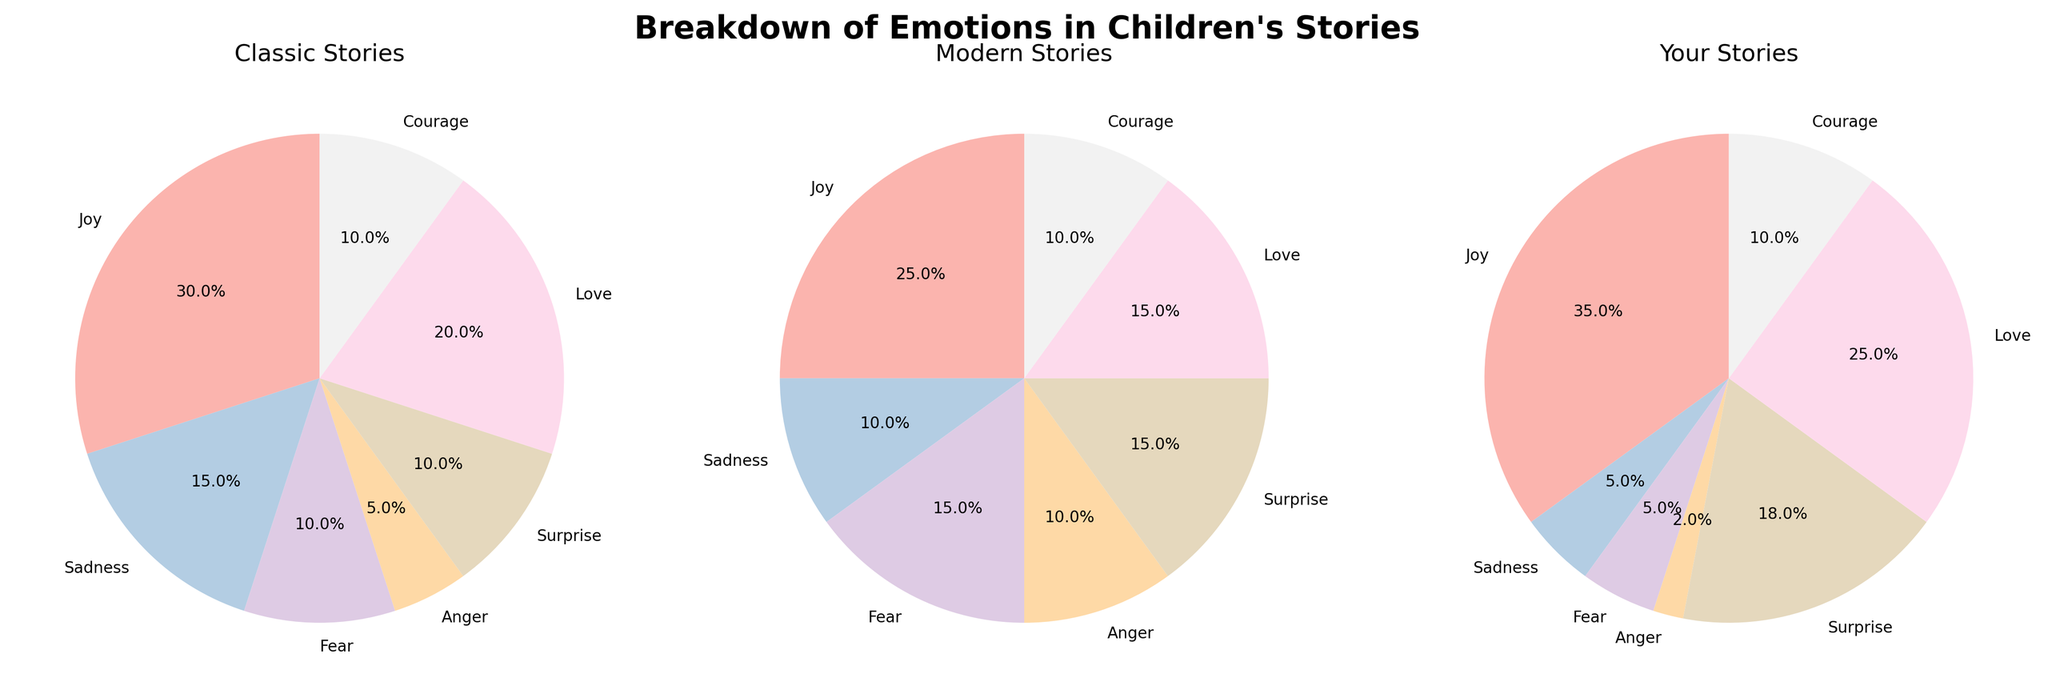Which story type has the highest percentage of 'Joy' depicted? To determine which story type has the highest percentage of 'Joy,' look at each pie chart's section labeled 'Joy' and compare their percentages. 'Your Stories' have 35%, which is higher than the other two categories.
Answer: Your Stories What is the combined percentage of 'Fear' and 'Sadness' in Classic Stories? Add the percentages of 'Fear' (10%) and 'Sadness' (15%) in Classic Stories. 10% + 15% equals 25%.
Answer: 25% Which emotion has the smallest representation in 'Your Stories'? Inspect the 'Your Stories' pie chart and identify the emotion with the smallest percentage. 'Anger' has 2%, which is the smallest representation.
Answer: Anger How does the percentage of 'Love' in Modern Stories compare to Classic Stories? Compare the 'Love' sections of both pie charts. In Modern Stories, 'Love' is 15%, while in Classic Stories, it is 20%. 'Love' is less in Modern Stories.
Answer: Less What percentage of all emotions in 'Modern Stories' are positive (Joy, Love, Courage)? Sum the percentages of 'Joy' (25%), 'Love' (15%), and 'Courage' (10%) in Modern Stories. 25% + 15% + 10% = 50%.
Answer: 50% Which emotion has the highest representation in Classic Stories? Identify the emotion with the largest percentage in the Classic Stories pie chart. 'Joy' has 30%, which is the highest.
Answer: Joy What is the difference in the percentage of 'Surprise' between Modern Stories and Your Stories? Subtract the percentage of 'Surprise' in Modern Stories (15%) from the percentage in Your Stories (18%). 18% - 15% = 3%.
Answer: 3% Are there any emotions with equal representation in Classic, Modern, and Your Stories? Look for emotions with the same percentage across all three pie charts. 'Courage' has 10% in all three story types.
Answer: Yes, Courage Which story type has the largest emotional variance among depicted emotions? Evaluate the spread of percentages for each story type: Classic Stories have a wide range from 5% to 30%, more varied than the others.
Answer: Classic Stories 